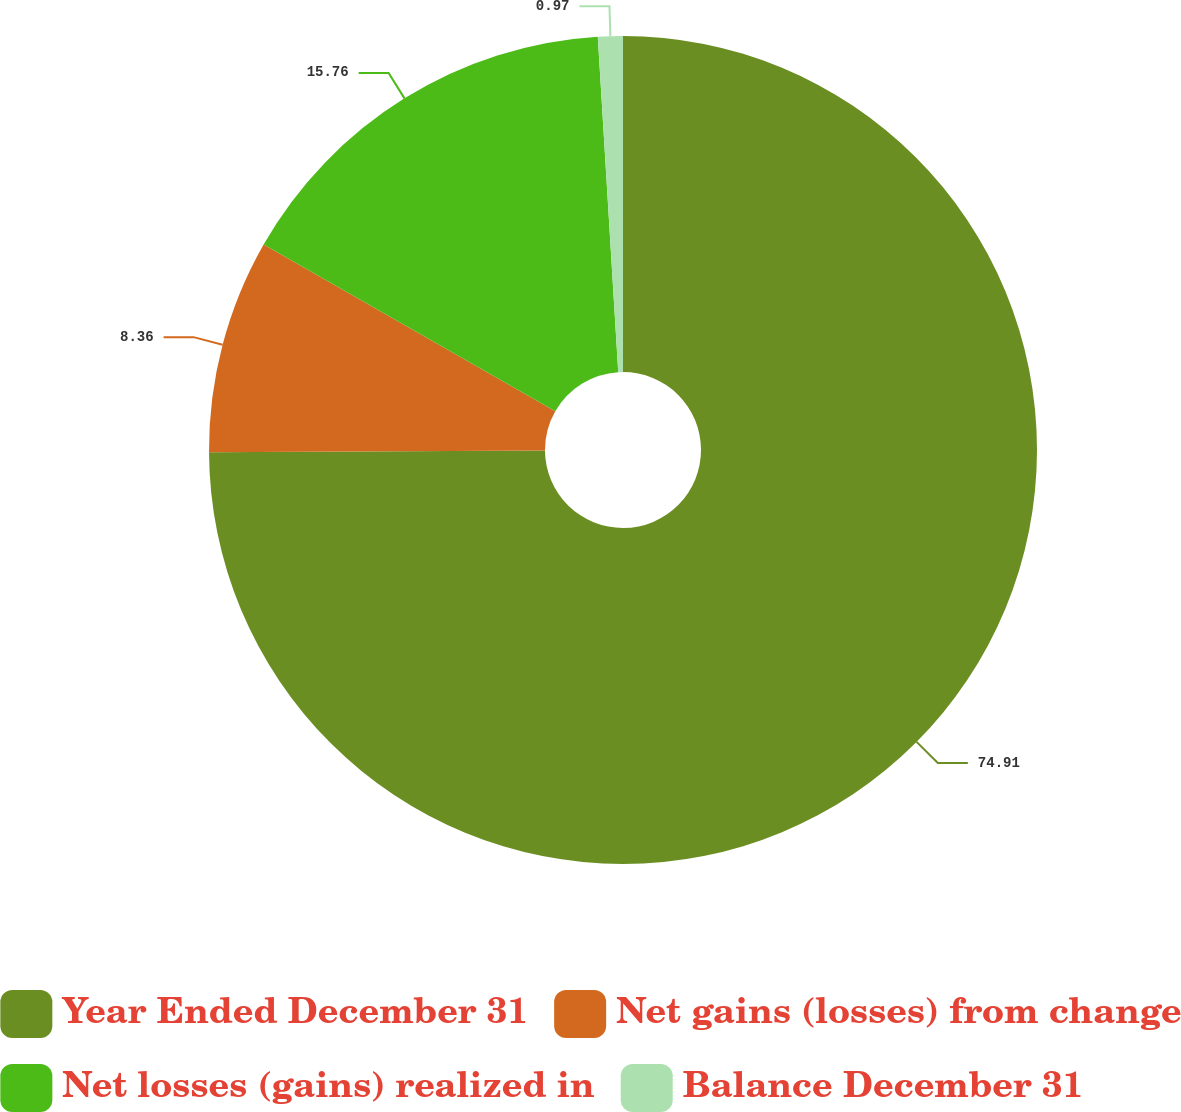<chart> <loc_0><loc_0><loc_500><loc_500><pie_chart><fcel>Year Ended December 31<fcel>Net gains (losses) from change<fcel>Net losses (gains) realized in<fcel>Balance December 31<nl><fcel>74.91%<fcel>8.36%<fcel>15.76%<fcel>0.97%<nl></chart> 